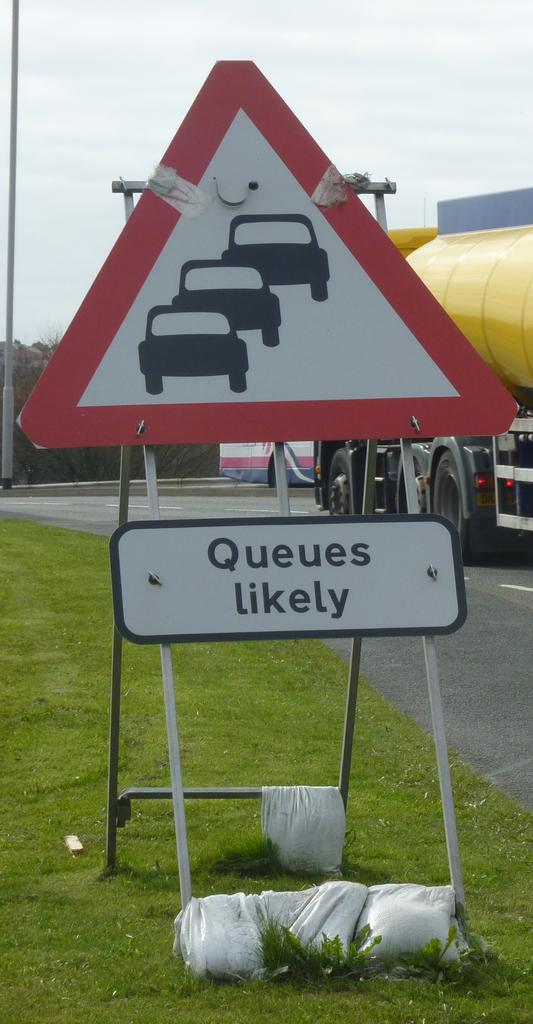<image>
Offer a succinct explanation of the picture presented. A sign that reads "Queues likely" sits on the side of the road 